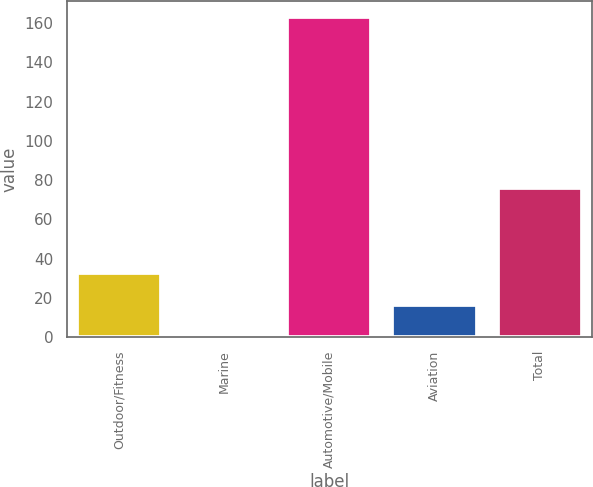<chart> <loc_0><loc_0><loc_500><loc_500><bar_chart><fcel>Outdoor/Fitness<fcel>Marine<fcel>Automotive/Mobile<fcel>Aviation<fcel>Total<nl><fcel>32.96<fcel>0.4<fcel>163.2<fcel>16.68<fcel>75.8<nl></chart> 